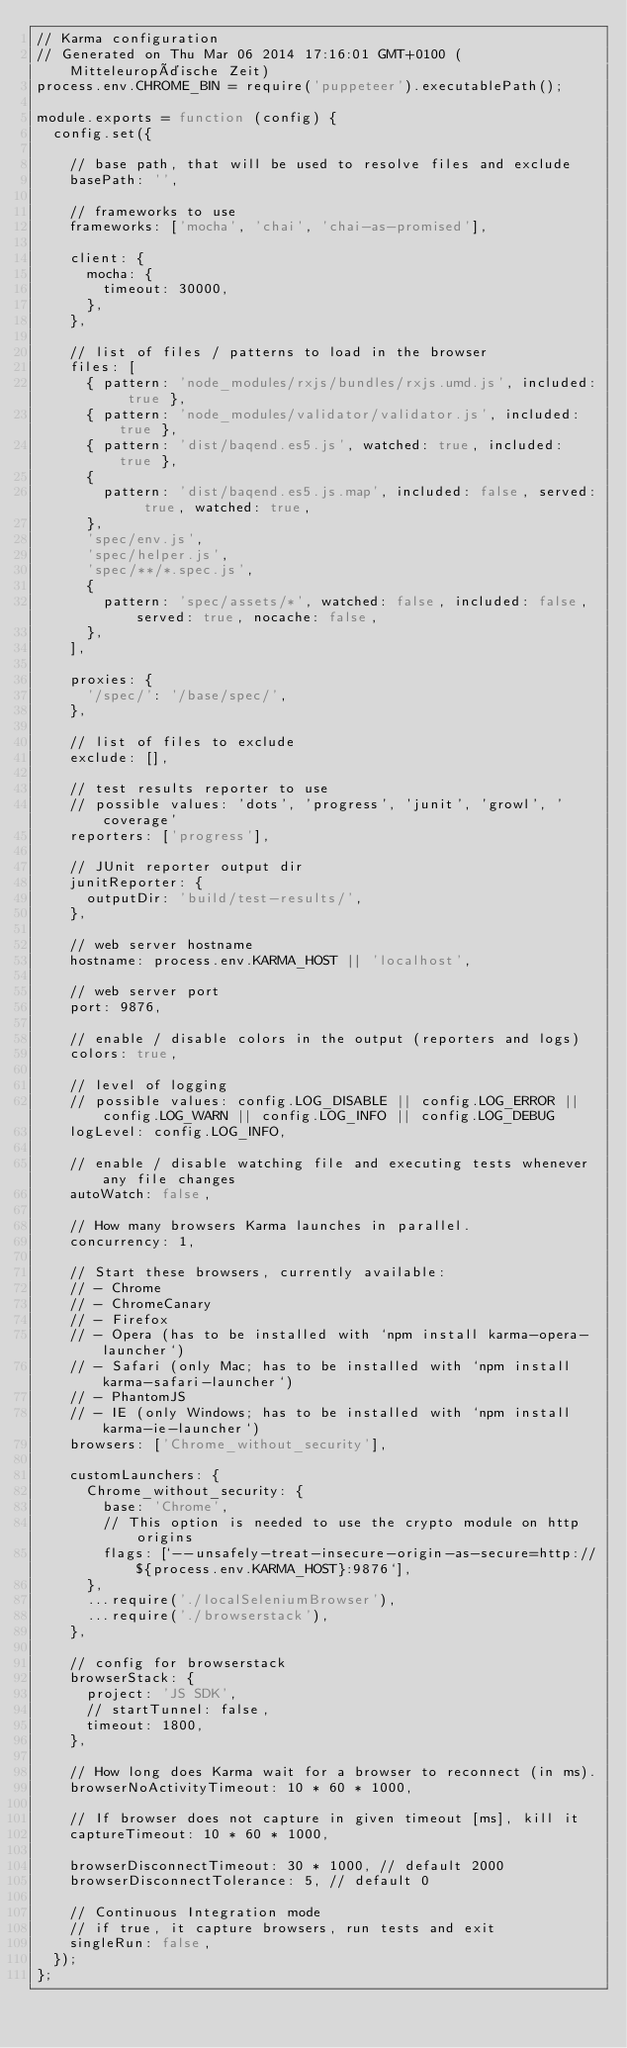<code> <loc_0><loc_0><loc_500><loc_500><_JavaScript_>// Karma configuration
// Generated on Thu Mar 06 2014 17:16:01 GMT+0100 (Mitteleuropäische Zeit)
process.env.CHROME_BIN = require('puppeteer').executablePath();

module.exports = function (config) {
  config.set({

    // base path, that will be used to resolve files and exclude
    basePath: '',

    // frameworks to use
    frameworks: ['mocha', 'chai', 'chai-as-promised'],

    client: {
      mocha: {
        timeout: 30000,
      },
    },

    // list of files / patterns to load in the browser
    files: [
      { pattern: 'node_modules/rxjs/bundles/rxjs.umd.js', included: true },
      { pattern: 'node_modules/validator/validator.js', included: true },
      { pattern: 'dist/baqend.es5.js', watched: true, included: true },
      {
        pattern: 'dist/baqend.es5.js.map', included: false, served: true, watched: true,
      },
      'spec/env.js',
      'spec/helper.js',
      'spec/**/*.spec.js',
      {
        pattern: 'spec/assets/*', watched: false, included: false, served: true, nocache: false,
      },
    ],

    proxies: {
      '/spec/': '/base/spec/',
    },

    // list of files to exclude
    exclude: [],

    // test results reporter to use
    // possible values: 'dots', 'progress', 'junit', 'growl', 'coverage'
    reporters: ['progress'],

    // JUnit reporter output dir
    junitReporter: {
      outputDir: 'build/test-results/',
    },

    // web server hostname
    hostname: process.env.KARMA_HOST || 'localhost',

    // web server port
    port: 9876,

    // enable / disable colors in the output (reporters and logs)
    colors: true,

    // level of logging
    // possible values: config.LOG_DISABLE || config.LOG_ERROR || config.LOG_WARN || config.LOG_INFO || config.LOG_DEBUG
    logLevel: config.LOG_INFO,

    // enable / disable watching file and executing tests whenever any file changes
    autoWatch: false,

    // How many browsers Karma launches in parallel.
    concurrency: 1,

    // Start these browsers, currently available:
    // - Chrome
    // - ChromeCanary
    // - Firefox
    // - Opera (has to be installed with `npm install karma-opera-launcher`)
    // - Safari (only Mac; has to be installed with `npm install karma-safari-launcher`)
    // - PhantomJS
    // - IE (only Windows; has to be installed with `npm install karma-ie-launcher`)
    browsers: ['Chrome_without_security'],

    customLaunchers: {
      Chrome_without_security: {
        base: 'Chrome',
        // This option is needed to use the crypto module on http origins
        flags: [`--unsafely-treat-insecure-origin-as-secure=http://${process.env.KARMA_HOST}:9876`],
      },
      ...require('./localSeleniumBrowser'),
      ...require('./browserstack'),
    },

    // config for browserstack
    browserStack: {
      project: 'JS SDK',
      // startTunnel: false,
      timeout: 1800,
    },

    // How long does Karma wait for a browser to reconnect (in ms).
    browserNoActivityTimeout: 10 * 60 * 1000,

    // If browser does not capture in given timeout [ms], kill it
    captureTimeout: 10 * 60 * 1000,

    browserDisconnectTimeout: 30 * 1000, // default 2000
    browserDisconnectTolerance: 5, // default 0

    // Continuous Integration mode
    // if true, it capture browsers, run tests and exit
    singleRun: false,
  });
};
</code> 